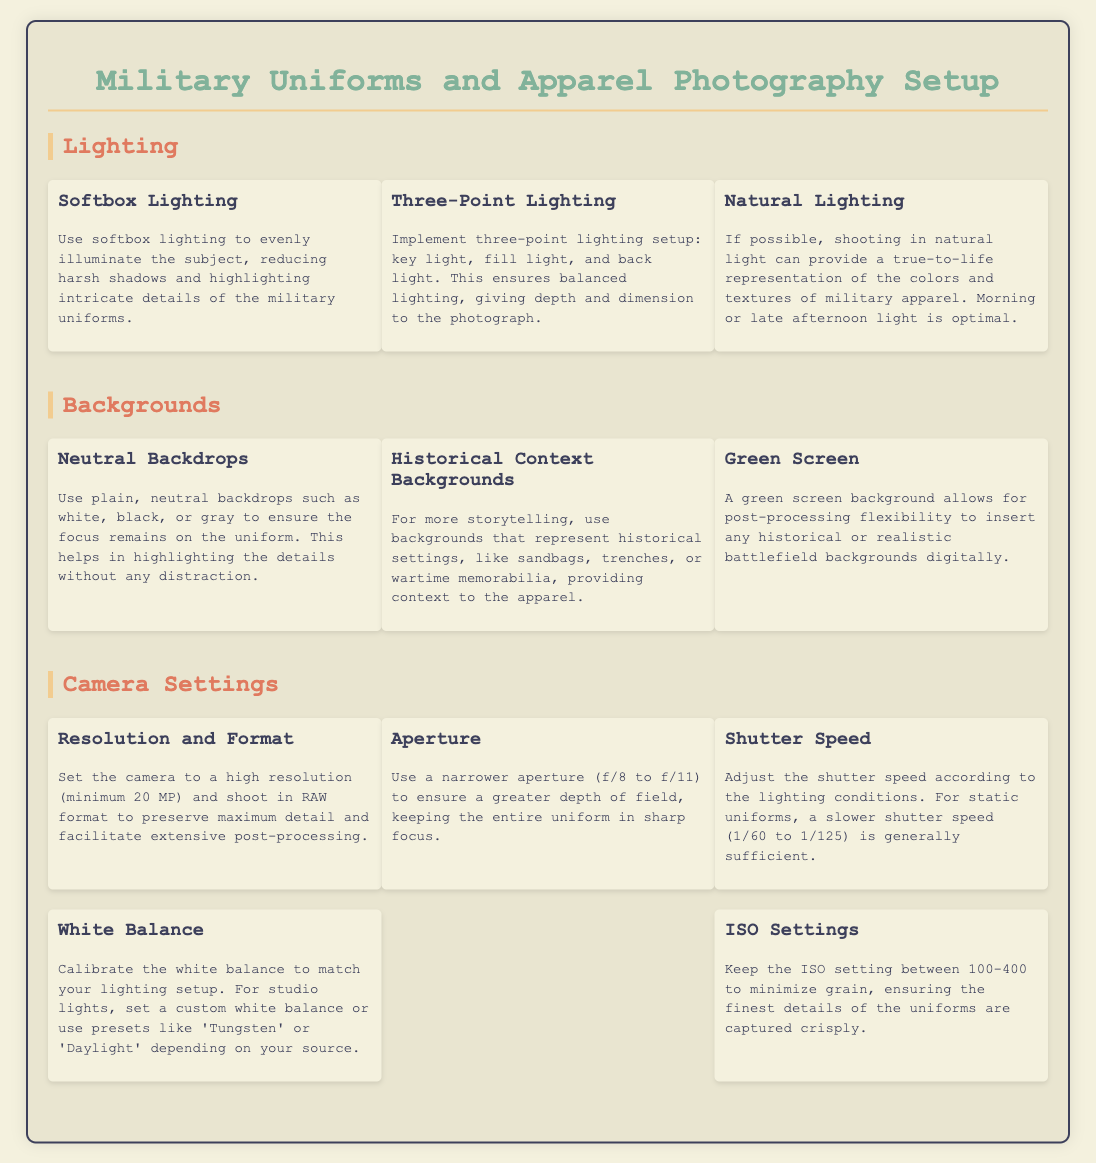What lighting setup is recommended for military apparel photography? The document suggests using a three-point lighting setup that includes key light, fill light, and back light for balanced lighting.
Answer: Three-Point Lighting What type of backdrops are suggested for military uniform photography? The document recommends plain, neutral backdrops like white, black, or gray to keep focus on the uniform.
Answer: Neutral Backdrops What is the minimum camera resolution recommended? The document specifies a high resolution of at least 20 MP for capturing maximum detail.
Answer: 20 MP What aperture setting is advised for greater depth of field? The document indicates using a narrower aperture from f/8 to f/11 for keeping the entire uniform in sharp focus.
Answer: f/8 to f/11 What is the recommended ISO setting range to minimize grain? The document suggests keeping the ISO setting between 100-400 to achieve better clarity in details.
Answer: 100-400 What type of lighting provides true-to-life color representations? The document states that natural lighting can offer the most accurate color representation of military apparel.
Answer: Natural Lighting What background option allows for digital post-processing flexibility? The document mentions using a green screen background for enhanced post-processing capabilities.
Answer: Green Screen What is the recommended shutter speed for static uniforms? The document suggests a slower shutter speed of 1/60 to 1/125 is generally sufficient for static uniforms.
Answer: 1/60 to 1/125 What is the primary goal of using softbox lighting in photography? The document describes the use of softbox lighting to evenly illuminate the subject and reduce harsh shadows.
Answer: Reduce harsh shadows 